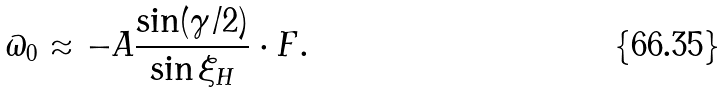Convert formula to latex. <formula><loc_0><loc_0><loc_500><loc_500>\varpi _ { 0 } \approx - A \frac { \sin ( \gamma / 2 ) } { \sin \xi _ { H } } \cdot F .</formula> 